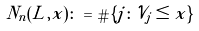<formula> <loc_0><loc_0><loc_500><loc_500>N _ { n } ( L , x ) \colon = \# \{ j \colon \mathcal { V } _ { j } \leq x \}</formula> 